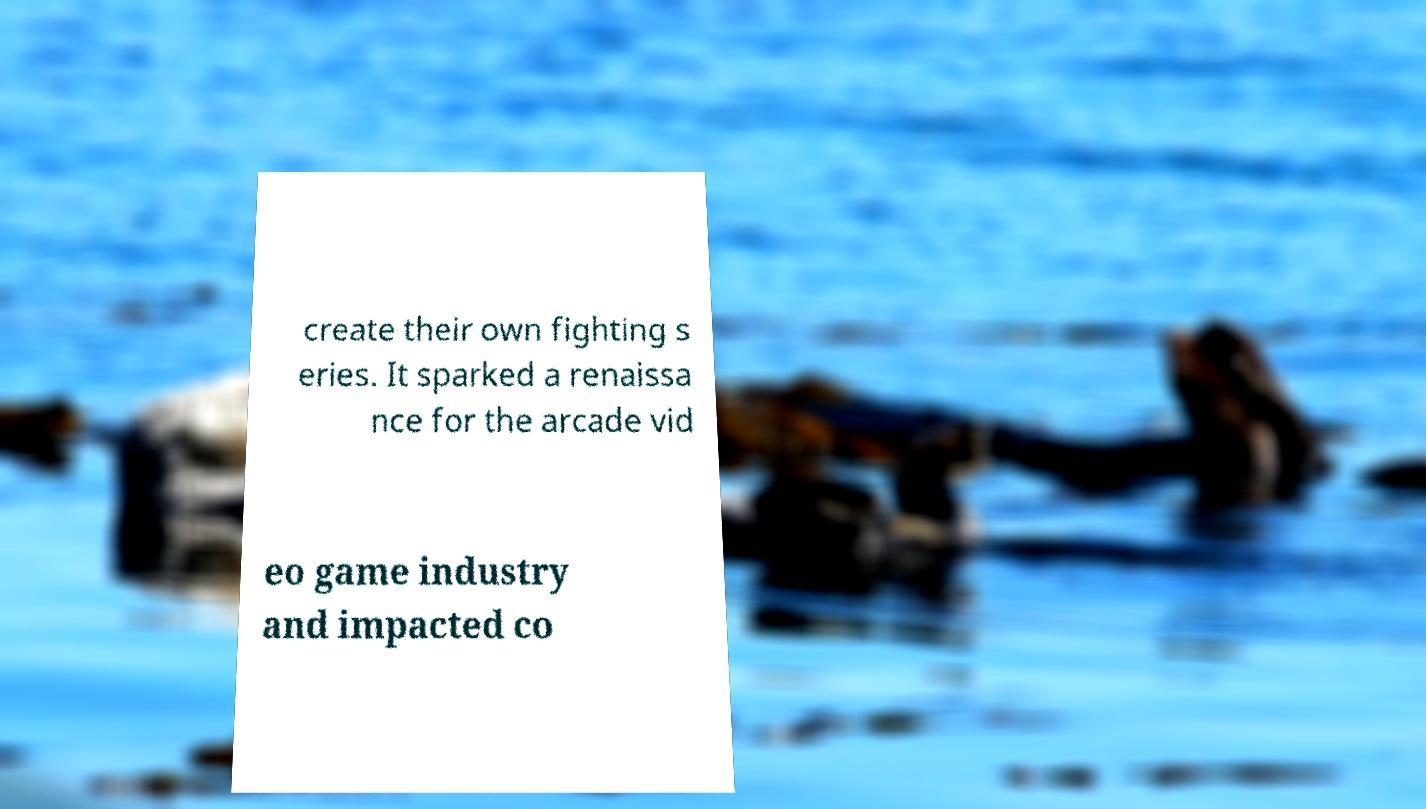For documentation purposes, I need the text within this image transcribed. Could you provide that? create their own fighting s eries. It sparked a renaissa nce for the arcade vid eo game industry and impacted co 